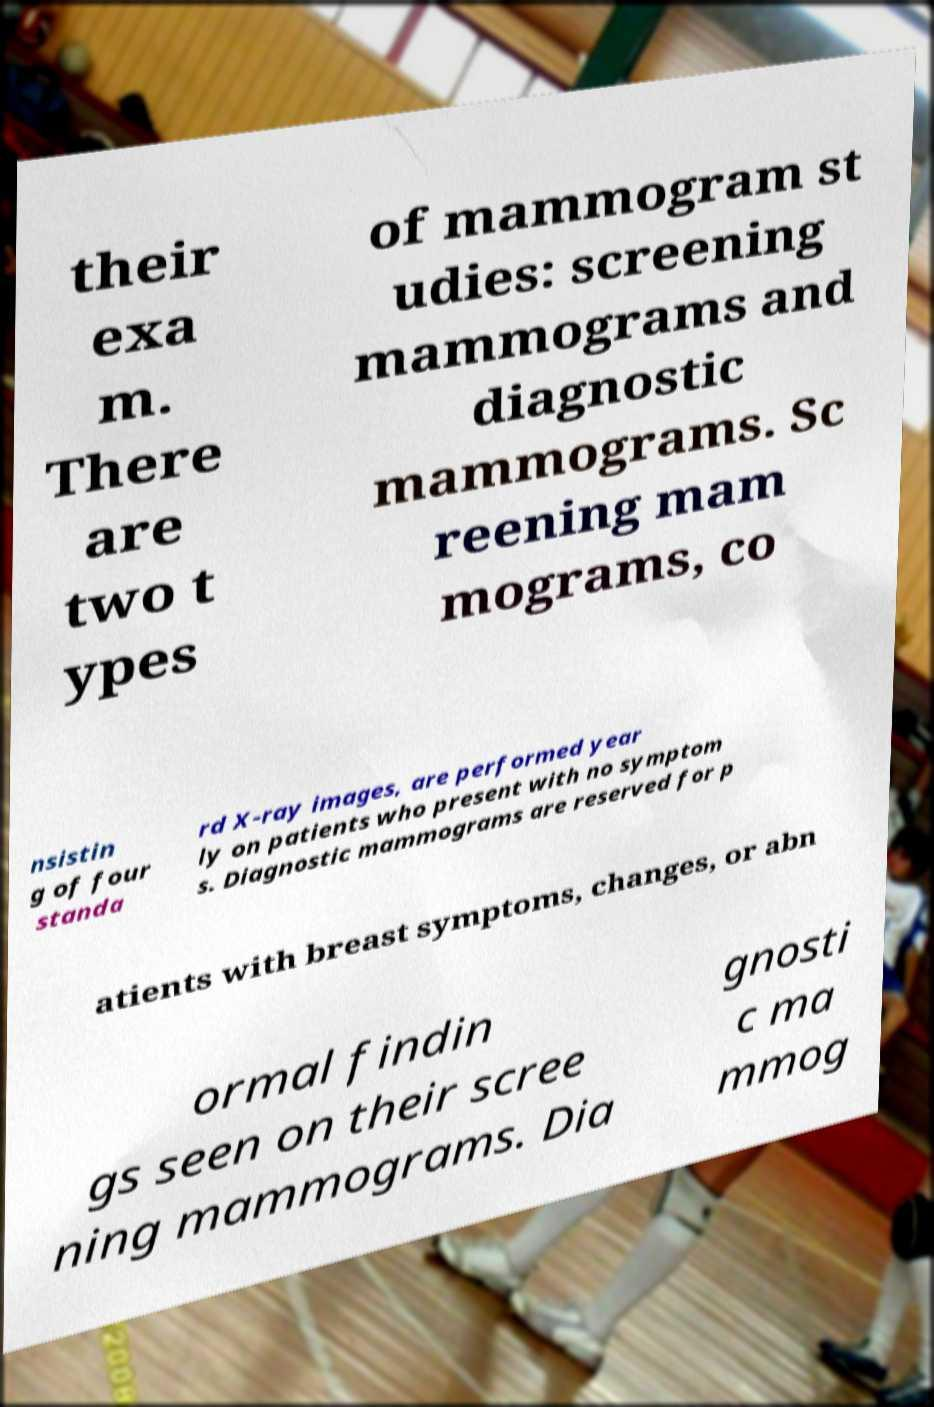I need the written content from this picture converted into text. Can you do that? their exa m. There are two t ypes of mammogram st udies: screening mammograms and diagnostic mammograms. Sc reening mam mograms, co nsistin g of four standa rd X-ray images, are performed year ly on patients who present with no symptom s. Diagnostic mammograms are reserved for p atients with breast symptoms, changes, or abn ormal findin gs seen on their scree ning mammograms. Dia gnosti c ma mmog 